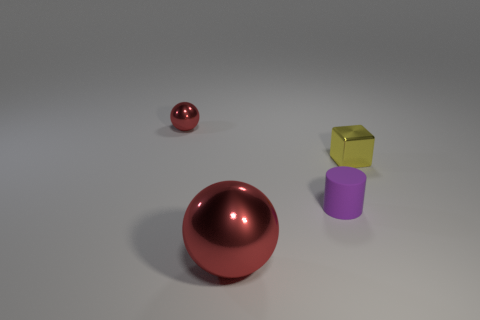The large red object in front of the yellow metal block that is in front of the red metal object behind the small matte object is made of what material?
Keep it short and to the point. Metal. How many rubber objects are small purple objects or small cyan blocks?
Your answer should be very brief. 1. How many purple things are rubber objects or big metallic balls?
Your response must be concise. 1. There is a large sphere that is to the left of the tiny matte cylinder; does it have the same color as the small ball?
Your answer should be very brief. Yes. Is the yellow object made of the same material as the tiny purple object?
Your response must be concise. No. Are there an equal number of small yellow cubes on the right side of the small yellow metallic block and metal balls on the right side of the tiny red shiny object?
Your response must be concise. No. The tiny shiny object that is right of the tiny thing that is left of the red sphere in front of the tiny cylinder is what shape?
Your answer should be very brief. Cube. Is the number of small cubes that are to the right of the tiny shiny ball greater than the number of small cyan matte cylinders?
Your response must be concise. Yes. Is the shape of the red thing that is behind the yellow object the same as  the purple matte object?
Provide a short and direct response. No. There is a cylinder right of the large metal ball; what is its material?
Your answer should be very brief. Rubber. 